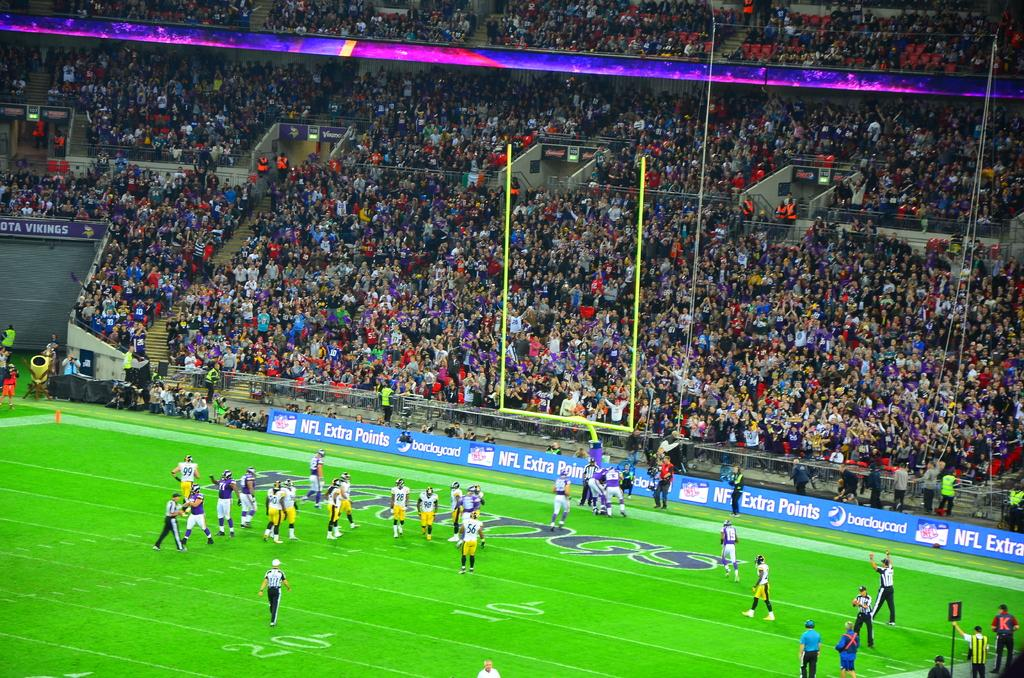<image>
Offer a succinct explanation of the picture presented. A football game with barclaycard ads played on the tickers. 